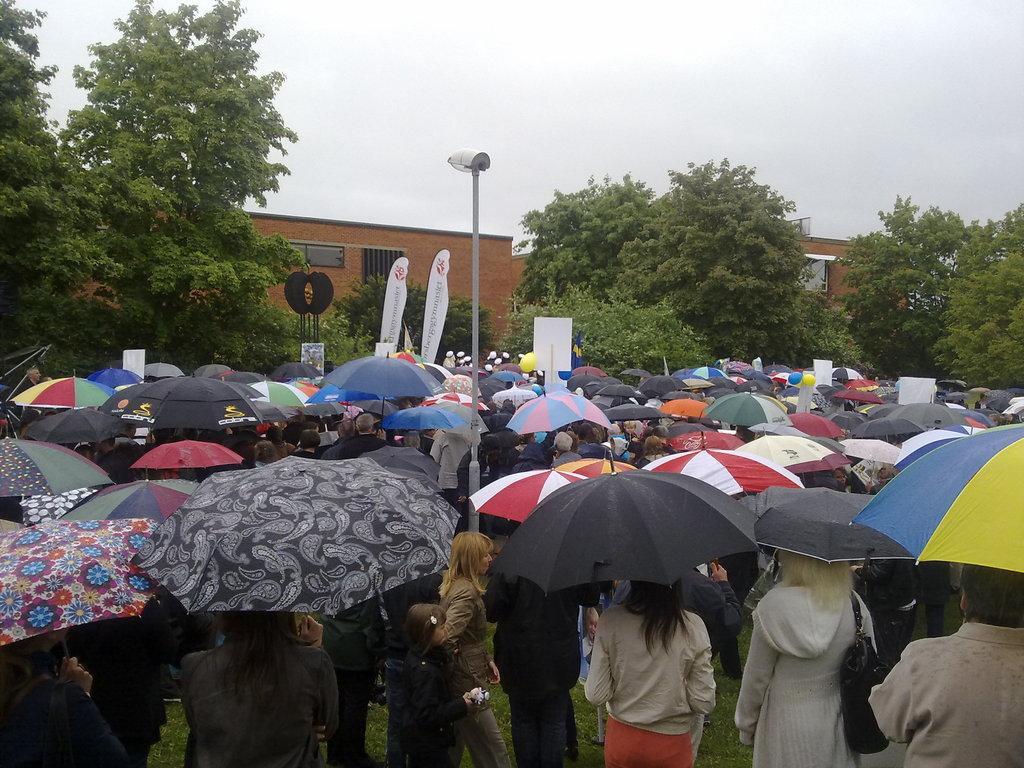Please provide a concise description of this image. In this picture, i can see buildings trees and a pole light and few banners, I can see few people standing, holding umbrellas and few placards in their hands and I can see a cloudy sky. 